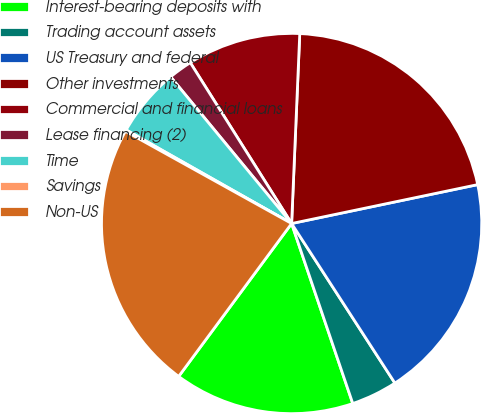<chart> <loc_0><loc_0><loc_500><loc_500><pie_chart><fcel>Interest-bearing deposits with<fcel>Trading account assets<fcel>US Treasury and federal<fcel>Other investments<fcel>Commercial and financial loans<fcel>Lease financing (2)<fcel>Time<fcel>Savings<fcel>Non-US<nl><fcel>15.34%<fcel>3.93%<fcel>19.14%<fcel>21.04%<fcel>9.63%<fcel>2.03%<fcel>5.83%<fcel>0.13%<fcel>22.94%<nl></chart> 